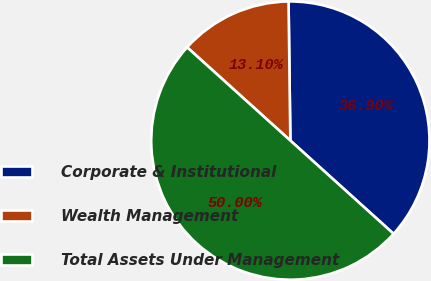<chart> <loc_0><loc_0><loc_500><loc_500><pie_chart><fcel>Corporate & Institutional<fcel>Wealth Management<fcel>Total Assets Under Management<nl><fcel>36.9%<fcel>13.1%<fcel>50.0%<nl></chart> 